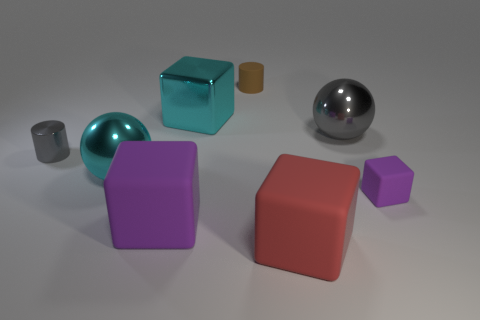Subtract 1 cubes. How many cubes are left? 3 Add 1 tiny brown objects. How many objects exist? 9 Subtract all cylinders. How many objects are left? 6 Add 7 large balls. How many large balls exist? 9 Subtract 1 red cubes. How many objects are left? 7 Subtract all big spheres. Subtract all gray metallic cylinders. How many objects are left? 5 Add 1 cyan balls. How many cyan balls are left? 2 